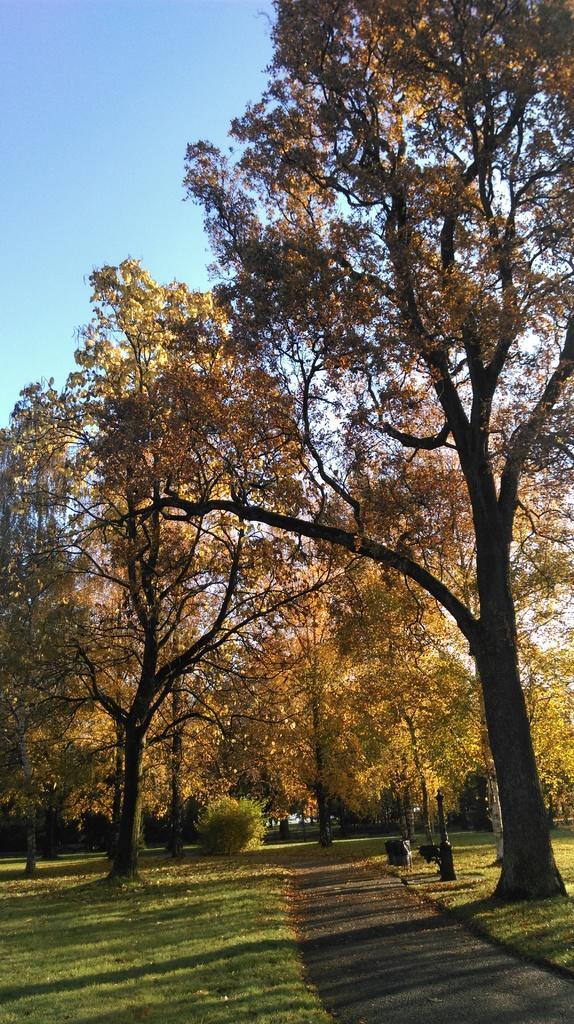Can you describe this image briefly? In this image we can see trees, grass, plant and the sky. 